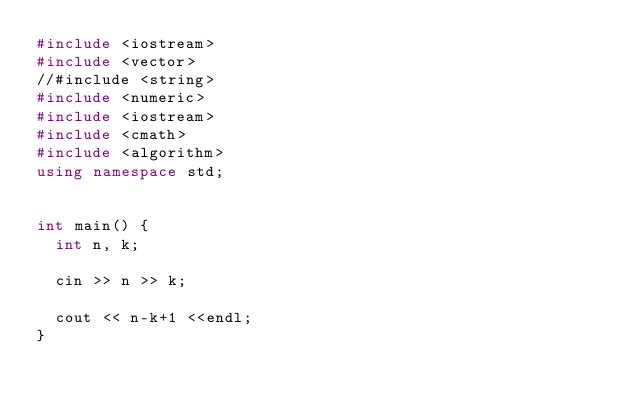<code> <loc_0><loc_0><loc_500><loc_500><_C++_>#include <iostream>
#include <vector>
//#include <string>
#include <numeric>
#include <iostream>
#include <cmath>
#include <algorithm>
using namespace std;


int main() {
  int n, k;
  
  cin >> n >> k;
  
  cout << n-k+1 <<endl;
}
</code> 